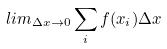Convert formula to latex. <formula><loc_0><loc_0><loc_500><loc_500>l i m _ { \Delta x \rightarrow 0 } \sum _ { i } f ( x _ { i } ) \Delta x</formula> 